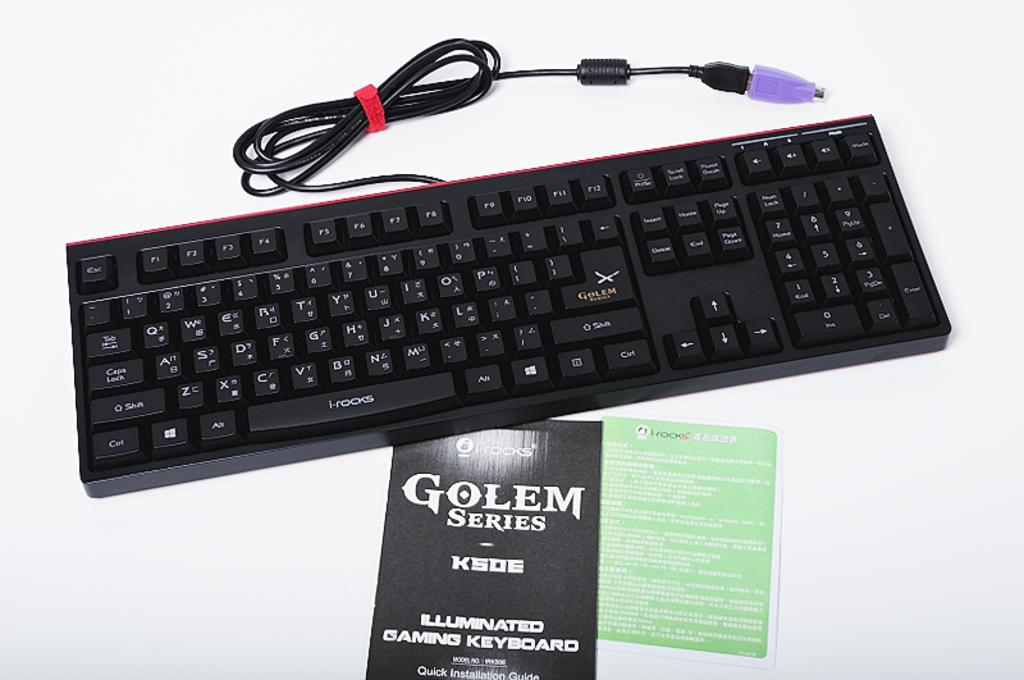<image>
Provide a brief description of the given image. A keyboard on top of a booklet of the keyboard called "Golem Series". 